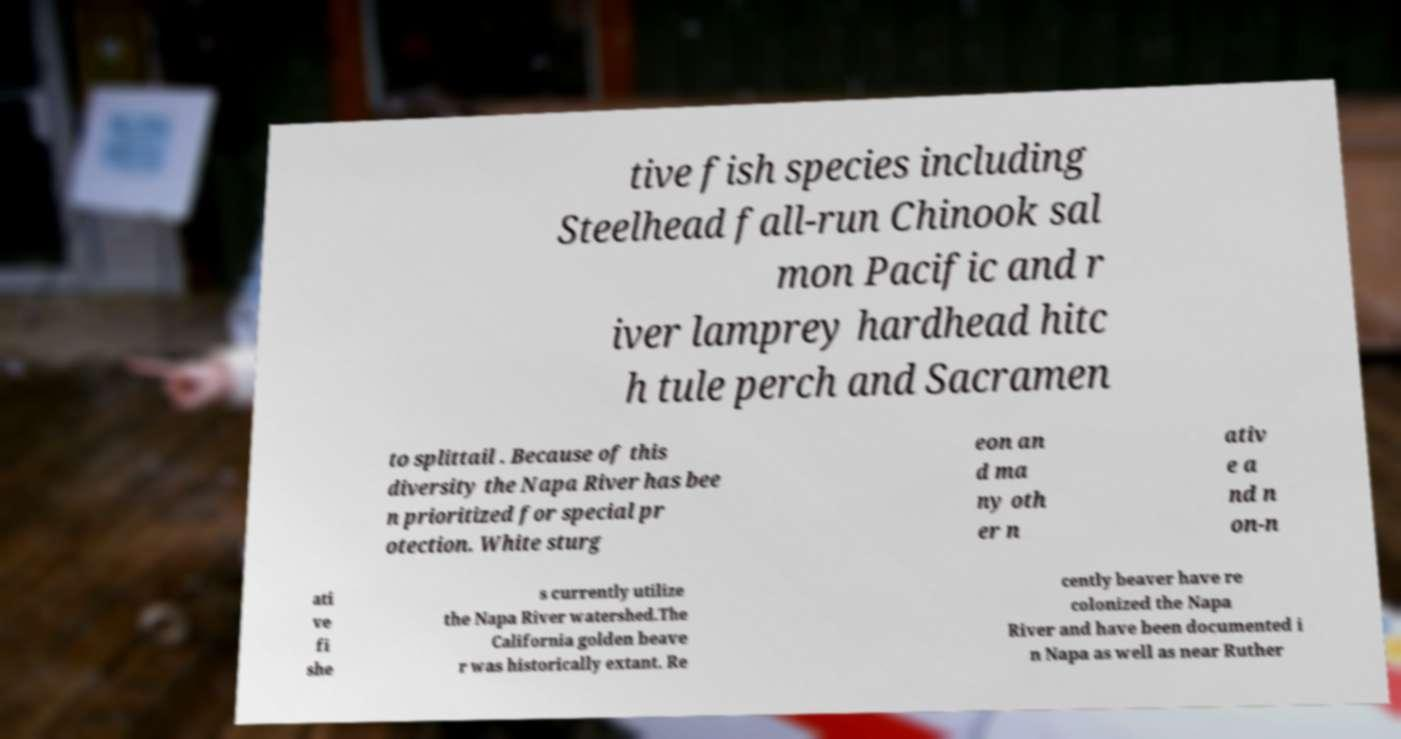What messages or text are displayed in this image? I need them in a readable, typed format. tive fish species including Steelhead fall-run Chinook sal mon Pacific and r iver lamprey hardhead hitc h tule perch and Sacramen to splittail . Because of this diversity the Napa River has bee n prioritized for special pr otection. White sturg eon an d ma ny oth er n ativ e a nd n on-n ati ve fi she s currently utilize the Napa River watershed.The California golden beave r was historically extant. Re cently beaver have re colonized the Napa River and have been documented i n Napa as well as near Ruther 